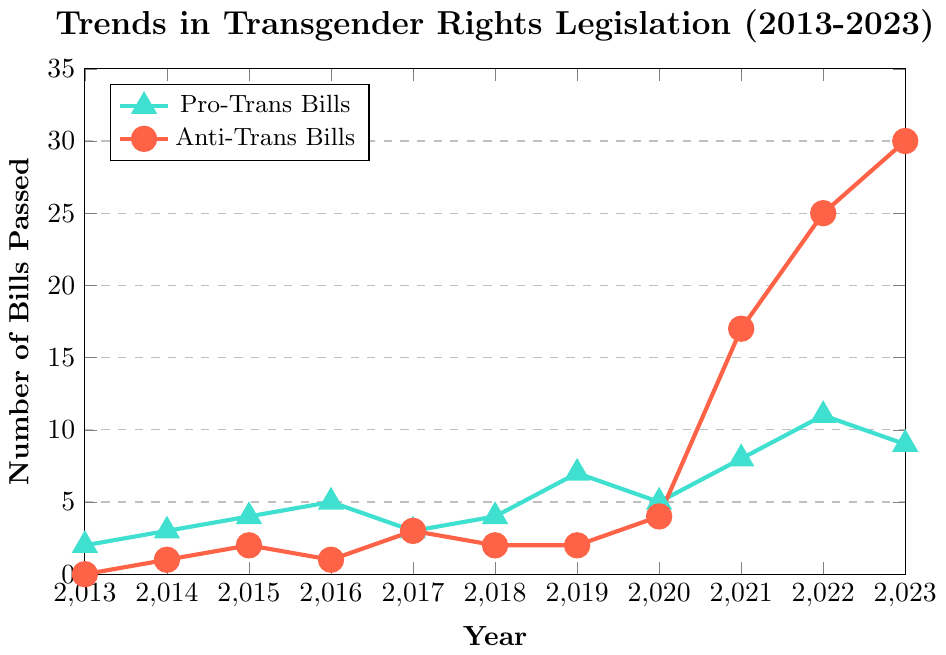Which year saw the highest number of anti-trans bills passed? The year with the highest number of anti-trans bills passed can be determined by looking at the peak of the red line on the plot.
Answer: 2023 How did the number of pro-trans bills passed in 2019 compare to the number in 2020? Compare the values of the turquoise line for the years 2019 and 2020. The plot shows 7 bills in 2019 and 5 bills in 2020, indicating a decrease.
Answer: Decreased What is the total number of anti-trans bills passed from 2018 to 2020 inclusive? Sum the values of anti-trans bills for the years 2018, 2019, and 2020 from the red line (2 + 2 + 4 = 8).
Answer: 8 Which year had more pro-trans bills passed, 2017 or 2018? Compare the values of the turquoise line for the years 2017 and 2018. In 2017, 3 bills were passed, and in 2018, 4 bills were passed.
Answer: 2018 In which year did the number of anti-trans bills passed see the most significant increase compared to the previous year? Determine the differences in the number of anti-trans bills passed between each year by comparing consecutive points on the red line. The most significant increase is between 2020 and 2021 (4 to 17).
Answer: 2021 What is the average number of pro-trans bills passed between 2013 and 2023? Calculate the sum of pro-trans bills for all years and divide by the number of years (2+3+4+5+3+4+7+5+8+11+9 = 61, 61/11 ≈ 5.55).
Answer: 5.55 How did the number of anti-trans bills in 2021 compare to the number of pro-trans bills in the same year? Compare the values of the red line (anti-trans) and turquoise line (pro-trans) for 2021. There were 17 anti-trans bills and 8 pro-trans bills.
Answer: More What was the trend of pro-trans bills from 2013 to 2023? Analyze the general direction of the values on the turquoise line. The trend shows a gradual increase with some fluctuations.
Answer: Gradual increase What is the difference in the number of anti-trans bills passed between 2014 and 2017? Subtract the number of anti-trans bills passed in 2014 from those in 2017 (3 - 1 = 2).
Answer: 2 What proportion of the total number of bills passed in 2023 were pro-trans bills? Add the number of pro-trans and anti-trans bills for 2023, and then calculate the proportion of pro-trans bills (9 out of 39, 9/39 ≈ 0.23).
Answer: 0.23 